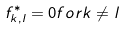<formula> <loc_0><loc_0><loc_500><loc_500>f ^ { * } _ { k , l } = 0 f o r k \not = l</formula> 